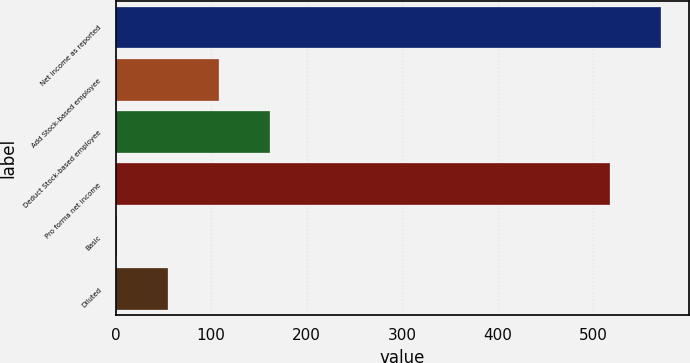<chart> <loc_0><loc_0><loc_500><loc_500><bar_chart><fcel>Net income as reported<fcel>Add Stock-based employee<fcel>Deduct Stock-based employee<fcel>Pro forma net income<fcel>Basic<fcel>Diluted<nl><fcel>571.36<fcel>108.09<fcel>161.45<fcel>518<fcel>1.37<fcel>54.73<nl></chart> 